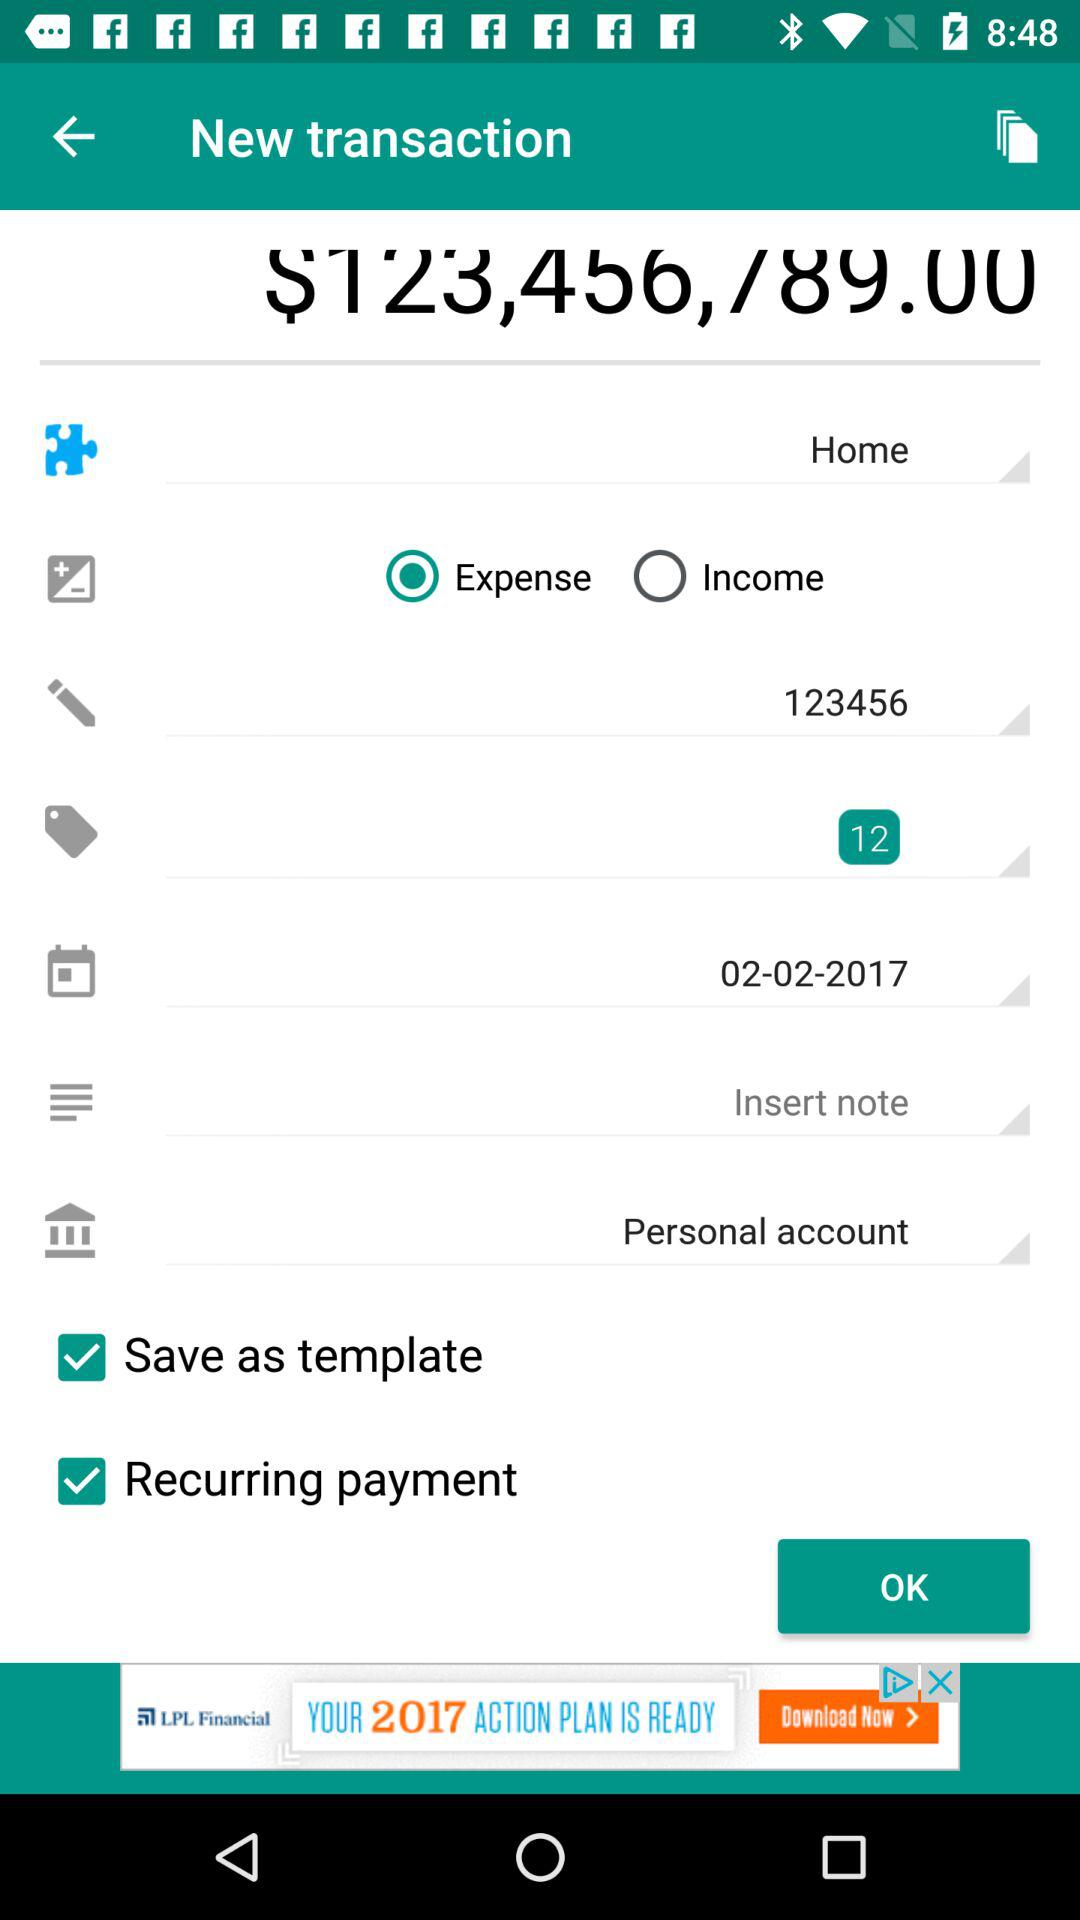What is the number of tags? The number of tags is 12. 